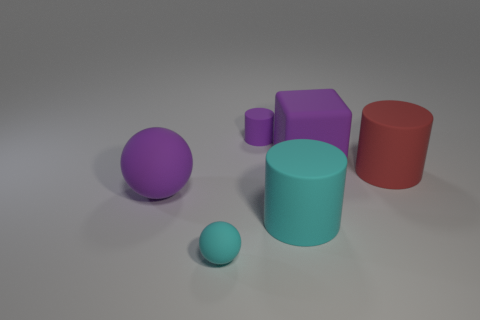Subtract all big cyan rubber cylinders. How many cylinders are left? 2 Add 4 large red cylinders. How many objects exist? 10 Subtract all red cylinders. How many cylinders are left? 2 Subtract all small green balls. Subtract all purple cylinders. How many objects are left? 5 Add 1 large purple cubes. How many large purple cubes are left? 2 Add 1 big gray matte things. How many big gray matte things exist? 1 Subtract 1 purple spheres. How many objects are left? 5 Subtract all balls. How many objects are left? 4 Subtract all brown blocks. Subtract all cyan cylinders. How many blocks are left? 1 Subtract all gray balls. How many gray blocks are left? 0 